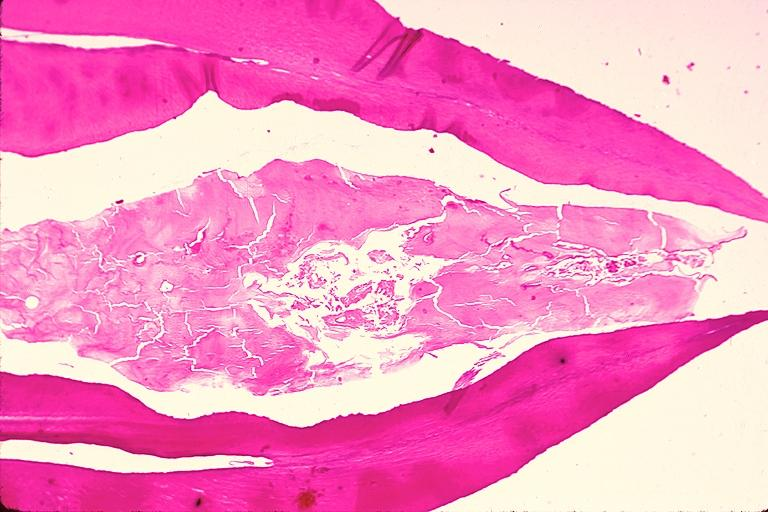s meningitis acute present?
Answer the question using a single word or phrase. No 